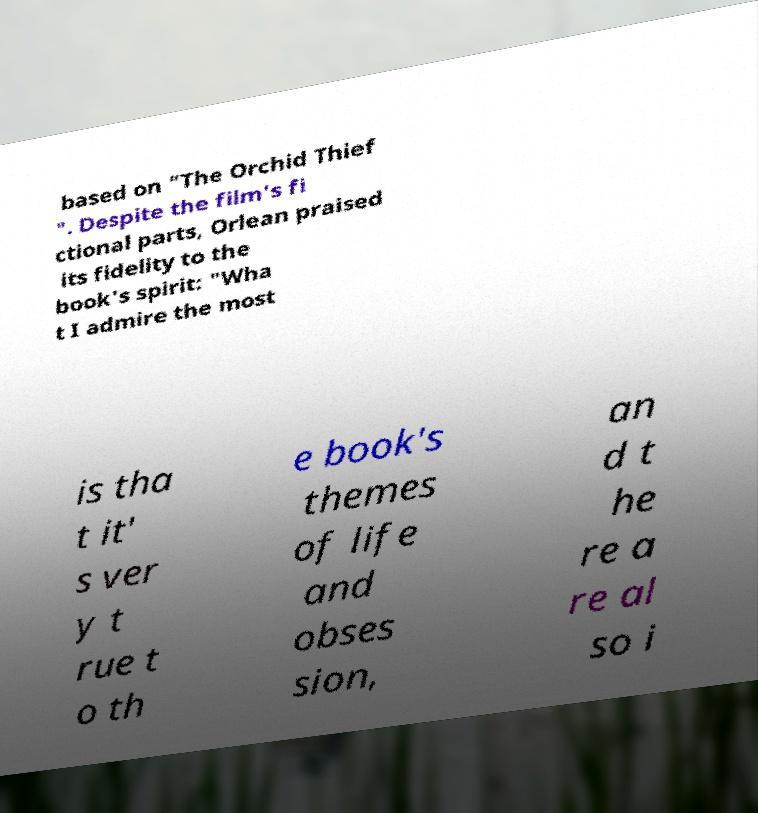There's text embedded in this image that I need extracted. Can you transcribe it verbatim? based on "The Orchid Thief ". Despite the film's fi ctional parts, Orlean praised its fidelity to the book's spirit: "Wha t I admire the most is tha t it' s ver y t rue t o th e book's themes of life and obses sion, an d t he re a re al so i 